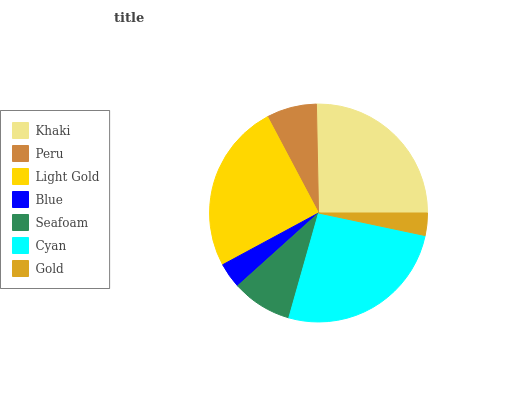Is Gold the minimum?
Answer yes or no. Yes. Is Cyan the maximum?
Answer yes or no. Yes. Is Peru the minimum?
Answer yes or no. No. Is Peru the maximum?
Answer yes or no. No. Is Khaki greater than Peru?
Answer yes or no. Yes. Is Peru less than Khaki?
Answer yes or no. Yes. Is Peru greater than Khaki?
Answer yes or no. No. Is Khaki less than Peru?
Answer yes or no. No. Is Seafoam the high median?
Answer yes or no. Yes. Is Seafoam the low median?
Answer yes or no. Yes. Is Blue the high median?
Answer yes or no. No. Is Blue the low median?
Answer yes or no. No. 